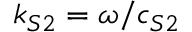Convert formula to latex. <formula><loc_0><loc_0><loc_500><loc_500>k _ { S 2 } = \omega / c _ { S 2 }</formula> 